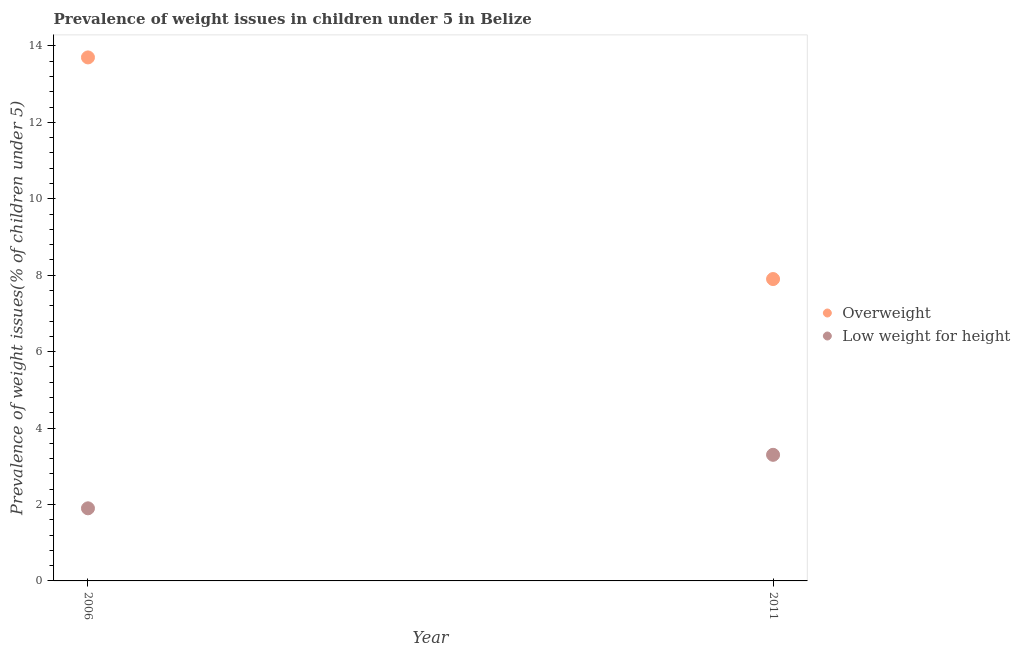How many different coloured dotlines are there?
Keep it short and to the point. 2. Is the number of dotlines equal to the number of legend labels?
Offer a very short reply. Yes. What is the percentage of overweight children in 2011?
Give a very brief answer. 7.9. Across all years, what is the maximum percentage of overweight children?
Ensure brevity in your answer.  13.7. Across all years, what is the minimum percentage of underweight children?
Provide a succinct answer. 1.9. What is the total percentage of overweight children in the graph?
Keep it short and to the point. 21.6. What is the difference between the percentage of overweight children in 2006 and that in 2011?
Offer a terse response. 5.8. What is the difference between the percentage of underweight children in 2011 and the percentage of overweight children in 2006?
Offer a very short reply. -10.4. What is the average percentage of overweight children per year?
Give a very brief answer. 10.8. In the year 2011, what is the difference between the percentage of underweight children and percentage of overweight children?
Offer a terse response. -4.6. What is the ratio of the percentage of overweight children in 2006 to that in 2011?
Provide a short and direct response. 1.73. Is the percentage of overweight children in 2006 less than that in 2011?
Your response must be concise. No. In how many years, is the percentage of overweight children greater than the average percentage of overweight children taken over all years?
Your response must be concise. 1. Does the percentage of underweight children monotonically increase over the years?
Offer a terse response. Yes. Is the percentage of underweight children strictly greater than the percentage of overweight children over the years?
Provide a short and direct response. No. Is the percentage of underweight children strictly less than the percentage of overweight children over the years?
Keep it short and to the point. Yes. How many dotlines are there?
Make the answer very short. 2. Are the values on the major ticks of Y-axis written in scientific E-notation?
Give a very brief answer. No. Does the graph contain any zero values?
Make the answer very short. No. Where does the legend appear in the graph?
Provide a short and direct response. Center right. How many legend labels are there?
Ensure brevity in your answer.  2. How are the legend labels stacked?
Provide a short and direct response. Vertical. What is the title of the graph?
Your response must be concise. Prevalence of weight issues in children under 5 in Belize. Does "IMF concessional" appear as one of the legend labels in the graph?
Provide a short and direct response. No. What is the label or title of the Y-axis?
Offer a very short reply. Prevalence of weight issues(% of children under 5). What is the Prevalence of weight issues(% of children under 5) of Overweight in 2006?
Provide a succinct answer. 13.7. What is the Prevalence of weight issues(% of children under 5) of Low weight for height in 2006?
Provide a succinct answer. 1.9. What is the Prevalence of weight issues(% of children under 5) of Overweight in 2011?
Make the answer very short. 7.9. What is the Prevalence of weight issues(% of children under 5) in Low weight for height in 2011?
Your answer should be very brief. 3.3. Across all years, what is the maximum Prevalence of weight issues(% of children under 5) of Overweight?
Give a very brief answer. 13.7. Across all years, what is the maximum Prevalence of weight issues(% of children under 5) in Low weight for height?
Your response must be concise. 3.3. Across all years, what is the minimum Prevalence of weight issues(% of children under 5) in Overweight?
Offer a terse response. 7.9. Across all years, what is the minimum Prevalence of weight issues(% of children under 5) in Low weight for height?
Ensure brevity in your answer.  1.9. What is the total Prevalence of weight issues(% of children under 5) in Overweight in the graph?
Your answer should be compact. 21.6. What is the total Prevalence of weight issues(% of children under 5) of Low weight for height in the graph?
Ensure brevity in your answer.  5.2. What is the difference between the Prevalence of weight issues(% of children under 5) in Overweight in 2006 and that in 2011?
Your answer should be compact. 5.8. What is the difference between the Prevalence of weight issues(% of children under 5) of Low weight for height in 2006 and that in 2011?
Give a very brief answer. -1.4. What is the average Prevalence of weight issues(% of children under 5) of Overweight per year?
Give a very brief answer. 10.8. What is the average Prevalence of weight issues(% of children under 5) in Low weight for height per year?
Your response must be concise. 2.6. In the year 2011, what is the difference between the Prevalence of weight issues(% of children under 5) in Overweight and Prevalence of weight issues(% of children under 5) in Low weight for height?
Ensure brevity in your answer.  4.6. What is the ratio of the Prevalence of weight issues(% of children under 5) of Overweight in 2006 to that in 2011?
Provide a short and direct response. 1.73. What is the ratio of the Prevalence of weight issues(% of children under 5) of Low weight for height in 2006 to that in 2011?
Offer a very short reply. 0.58. What is the difference between the highest and the second highest Prevalence of weight issues(% of children under 5) in Overweight?
Your answer should be compact. 5.8. What is the difference between the highest and the lowest Prevalence of weight issues(% of children under 5) of Low weight for height?
Keep it short and to the point. 1.4. 